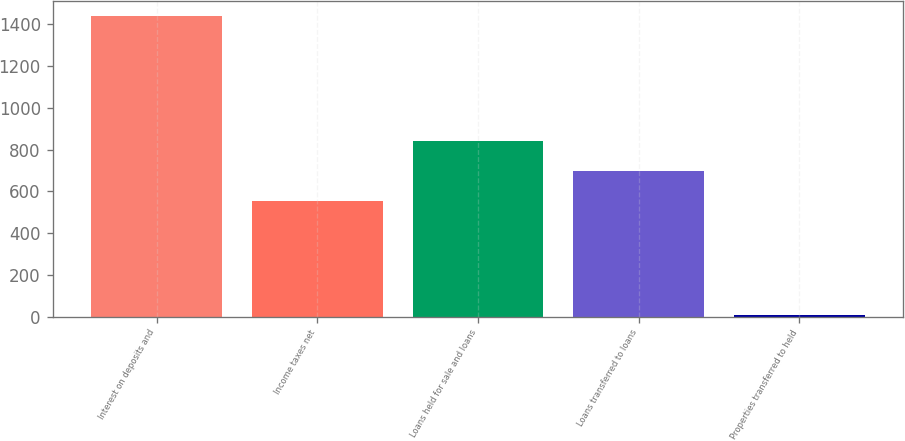Convert chart. <chart><loc_0><loc_0><loc_500><loc_500><bar_chart><fcel>Interest on deposits and<fcel>Income taxes net<fcel>Loans held for sale and loans<fcel>Loans transferred to loans<fcel>Properties transferred to held<nl><fcel>1442<fcel>555<fcel>842.2<fcel>698.6<fcel>6<nl></chart> 